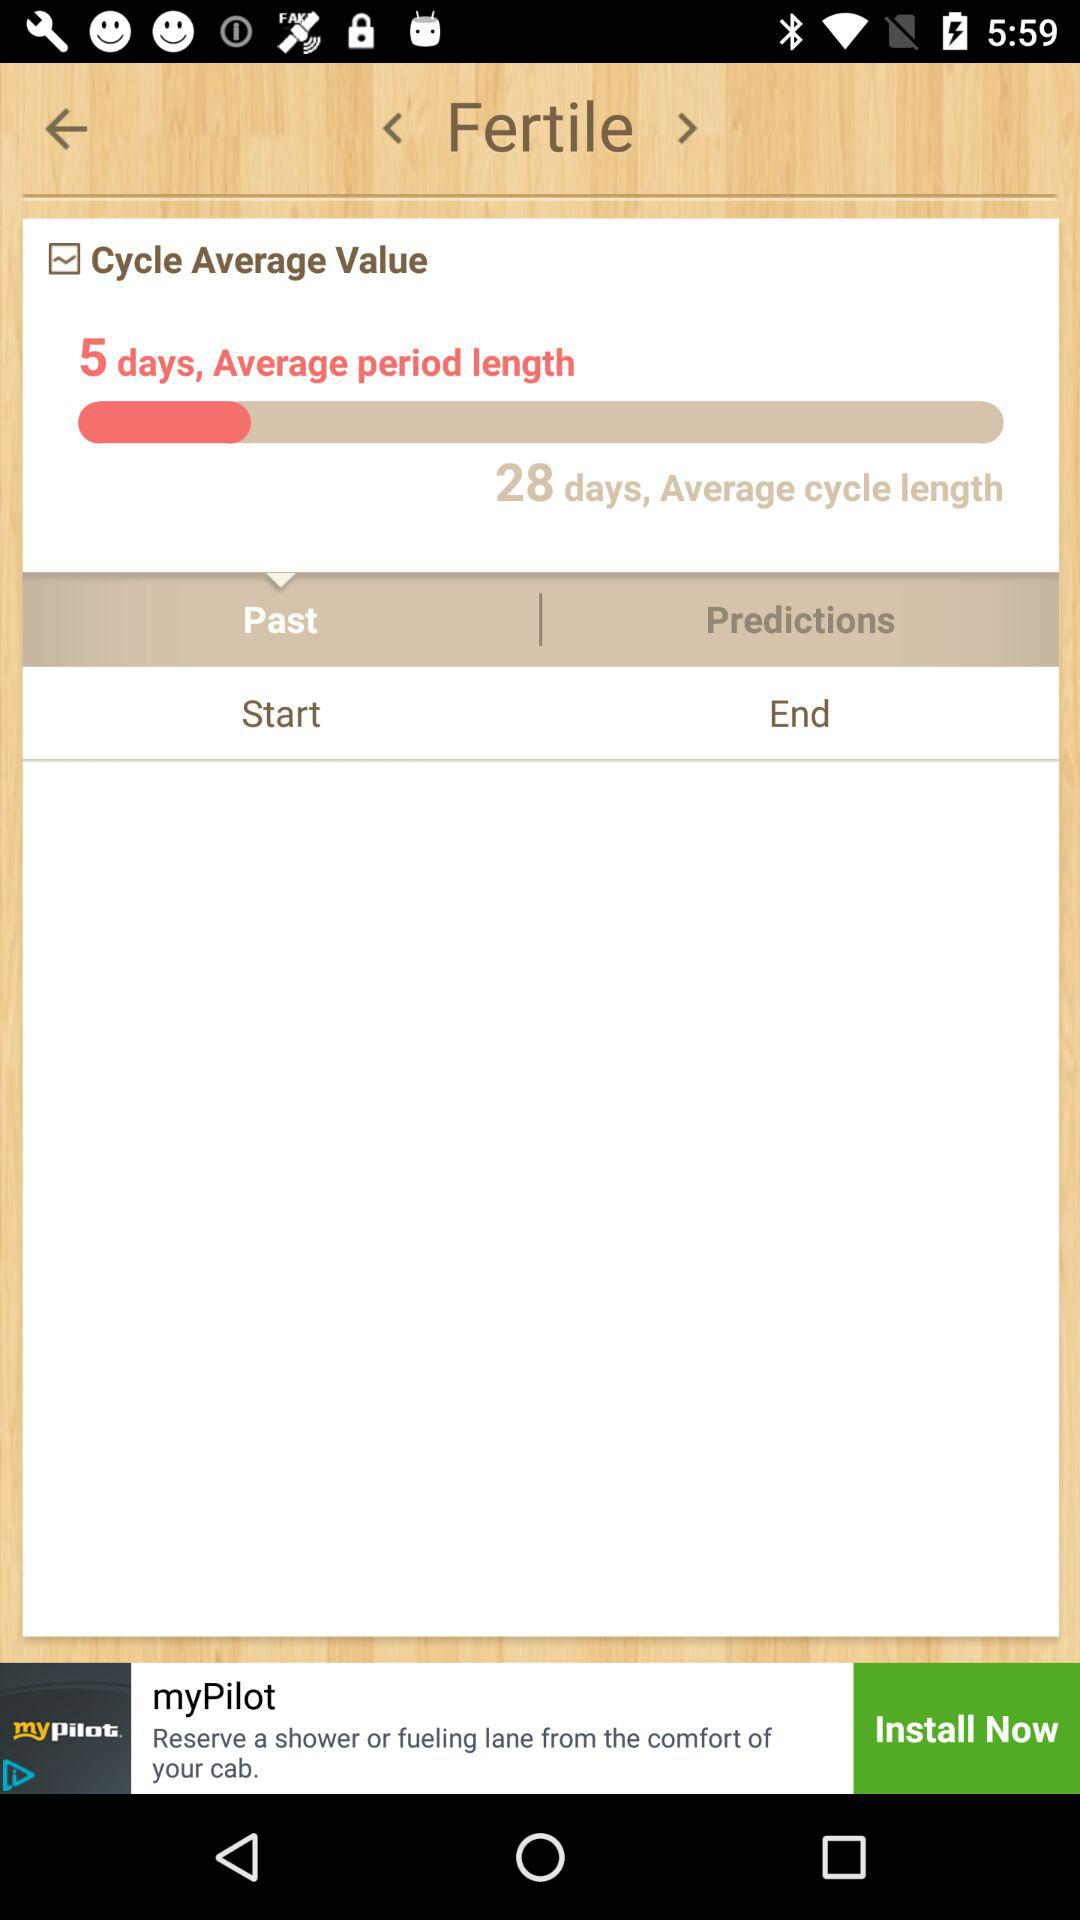What is the average period length? The average period length is 5 days. 